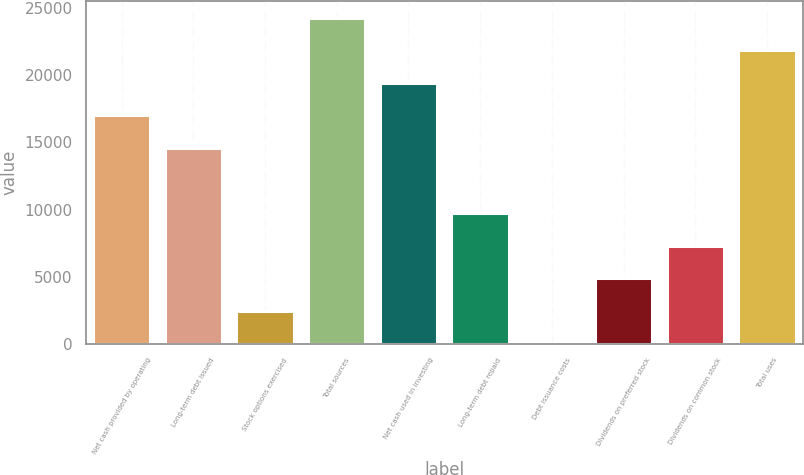Convert chart. <chart><loc_0><loc_0><loc_500><loc_500><bar_chart><fcel>Net cash provided by operating<fcel>Long-term debt issued<fcel>Stock options exercised<fcel>Total sources<fcel>Net cash used in investing<fcel>Long-term debt repaid<fcel>Debt issuance costs<fcel>Dividends on preferred stock<fcel>Dividends on common stock<fcel>Total uses<nl><fcel>17014.2<fcel>14585.6<fcel>2442.6<fcel>24300<fcel>19442.8<fcel>9728.4<fcel>14<fcel>4871.2<fcel>7299.8<fcel>21871.4<nl></chart> 